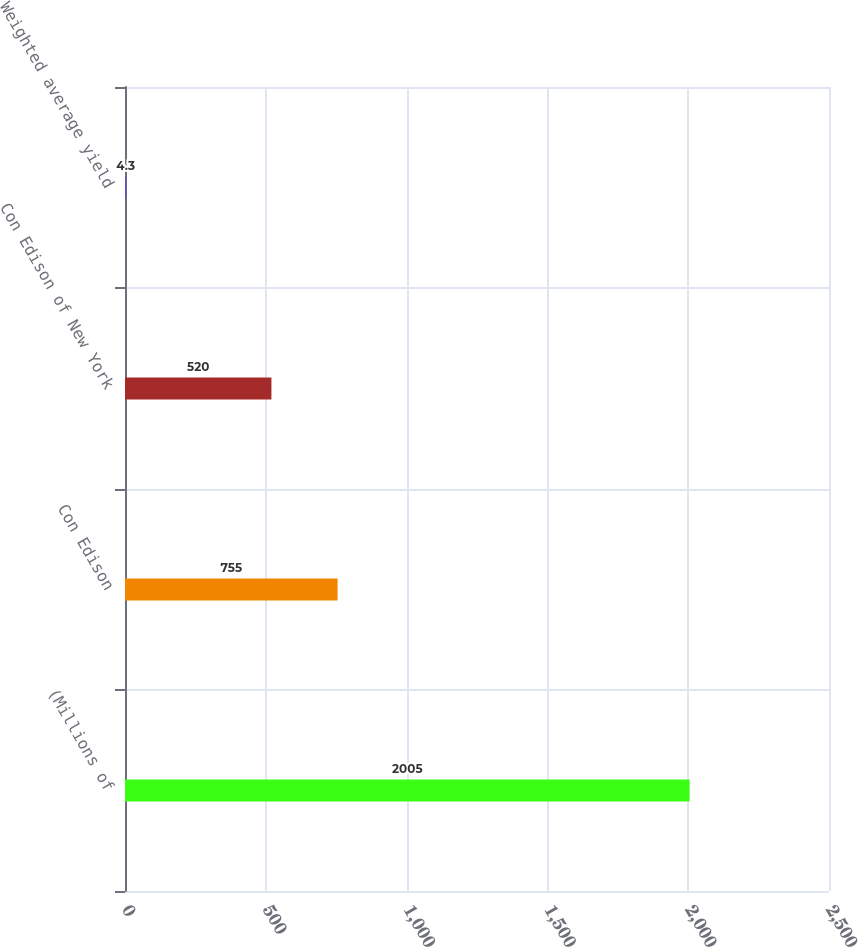<chart> <loc_0><loc_0><loc_500><loc_500><bar_chart><fcel>(Millions of<fcel>Con Edison<fcel>Con Edison of New York<fcel>Weighted average yield<nl><fcel>2005<fcel>755<fcel>520<fcel>4.3<nl></chart> 